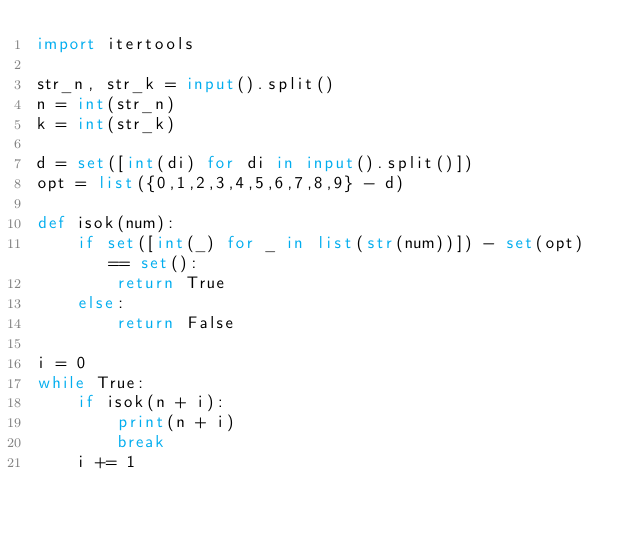Convert code to text. <code><loc_0><loc_0><loc_500><loc_500><_Python_>import itertools

str_n, str_k = input().split()
n = int(str_n)
k = int(str_k)

d = set([int(di) for di in input().split()])
opt = list({0,1,2,3,4,5,6,7,8,9} - d)

def isok(num):
    if set([int(_) for _ in list(str(num))]) - set(opt) == set():
        return True
    else:
        return False

i = 0
while True:
    if isok(n + i):
        print(n + i)
        break
    i += 1</code> 